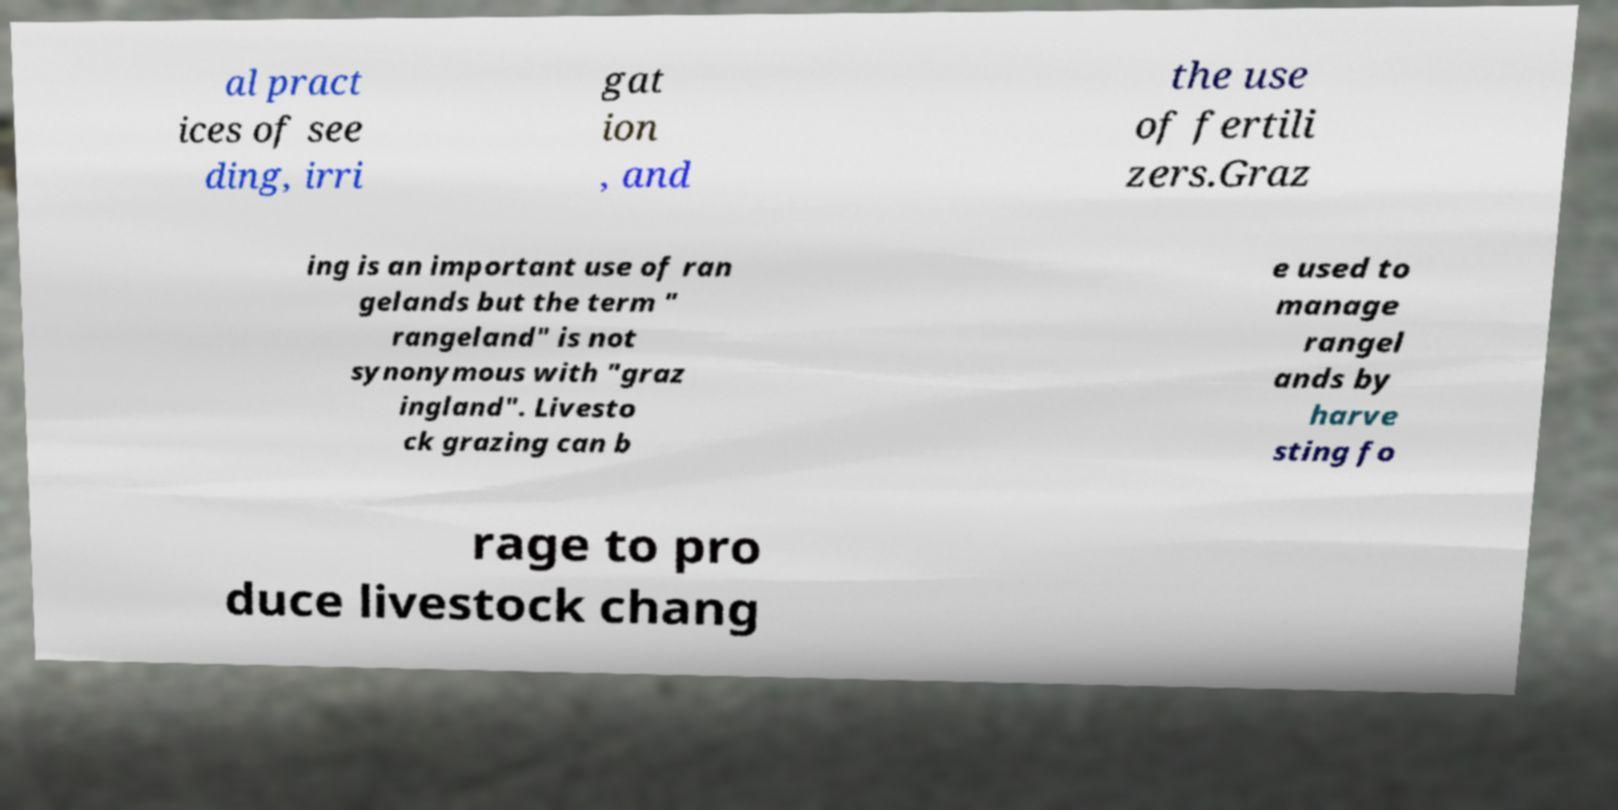For documentation purposes, I need the text within this image transcribed. Could you provide that? al pract ices of see ding, irri gat ion , and the use of fertili zers.Graz ing is an important use of ran gelands but the term " rangeland" is not synonymous with "graz ingland". Livesto ck grazing can b e used to manage rangel ands by harve sting fo rage to pro duce livestock chang 